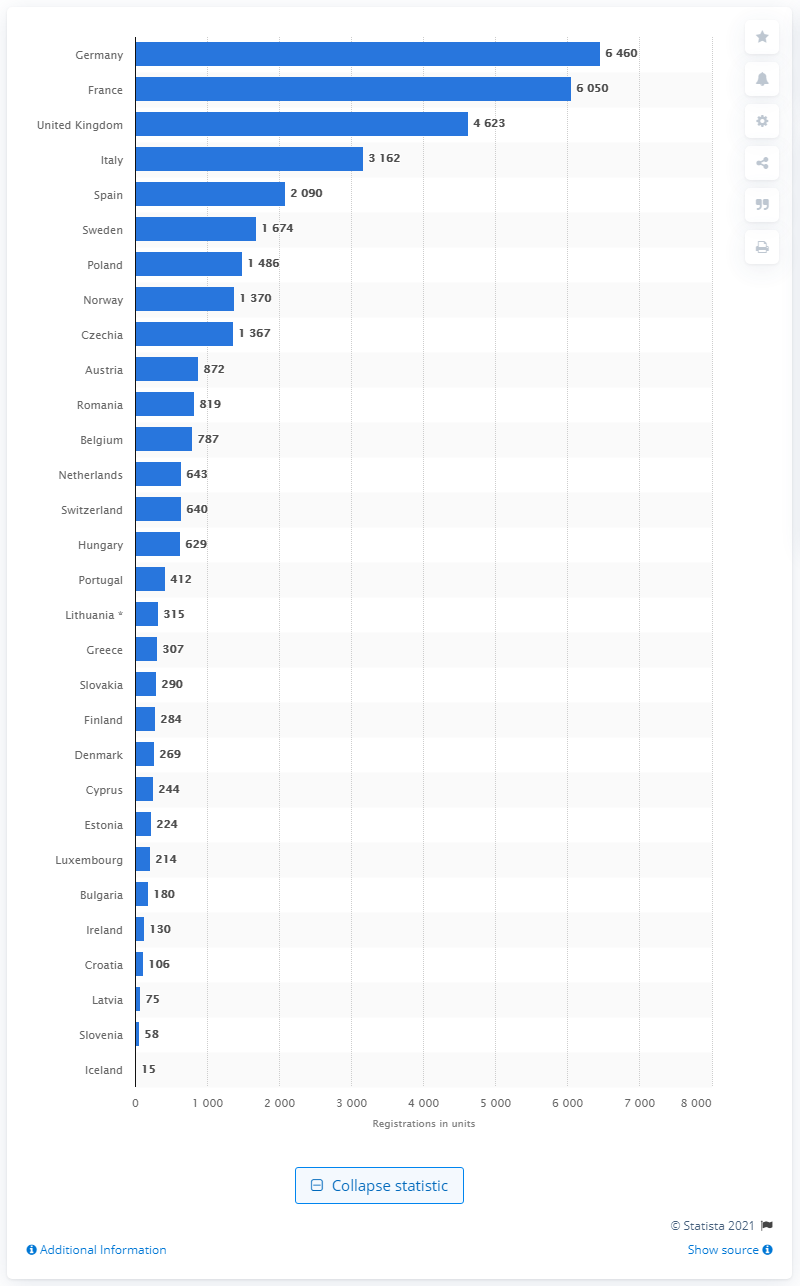Give some essential details in this illustration. In 2020, France had the highest number of new bus registrations compared to other countries. Germany is the leading country in Europe in terms of medium and heavy bus sales. 